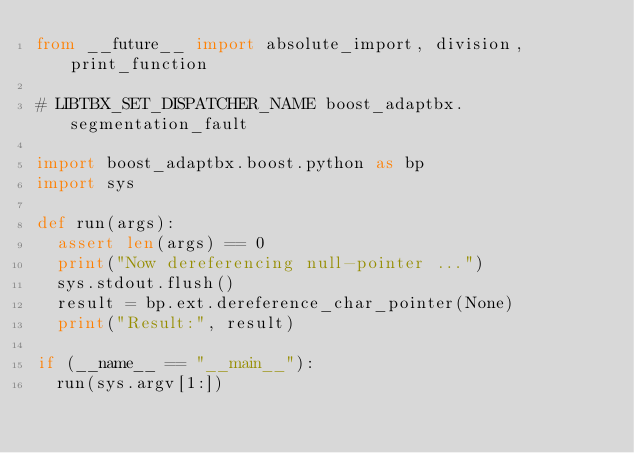<code> <loc_0><loc_0><loc_500><loc_500><_Python_>from __future__ import absolute_import, division, print_function

# LIBTBX_SET_DISPATCHER_NAME boost_adaptbx.segmentation_fault

import boost_adaptbx.boost.python as bp
import sys

def run(args):
  assert len(args) == 0
  print("Now dereferencing null-pointer ...")
  sys.stdout.flush()
  result = bp.ext.dereference_char_pointer(None)
  print("Result:", result)

if (__name__ == "__main__"):
  run(sys.argv[1:])
</code> 